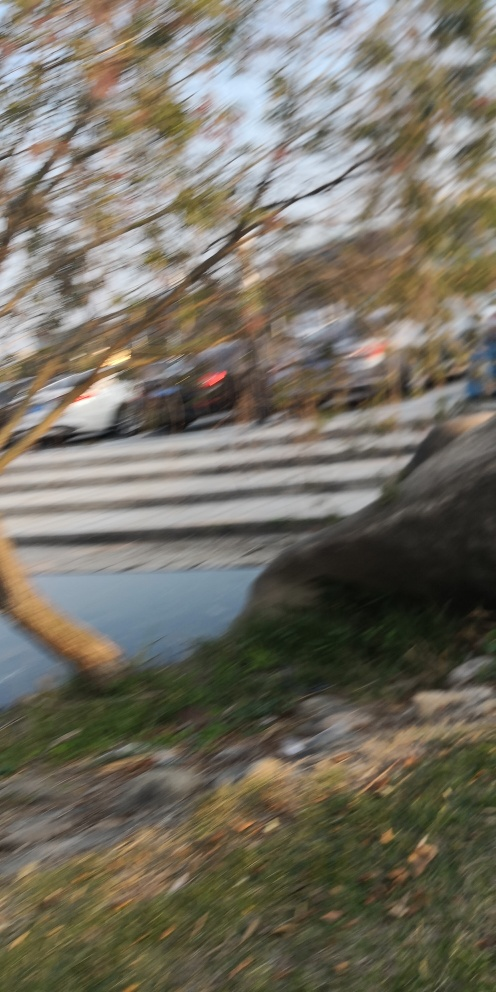Can you suggest how to avoid getting a blurred image like this one? To avoid a blurred image like this one, you could use a faster shutter speed, ensure your camera's focus is set correctly, use a tripod or other stable surface to avoid camera shake, and utilize image stabilization features if your camera has them. Additionally, be mindful of the lighting conditions, as low light can often lead to slower shutter speeds, which increases the risk of blur. 